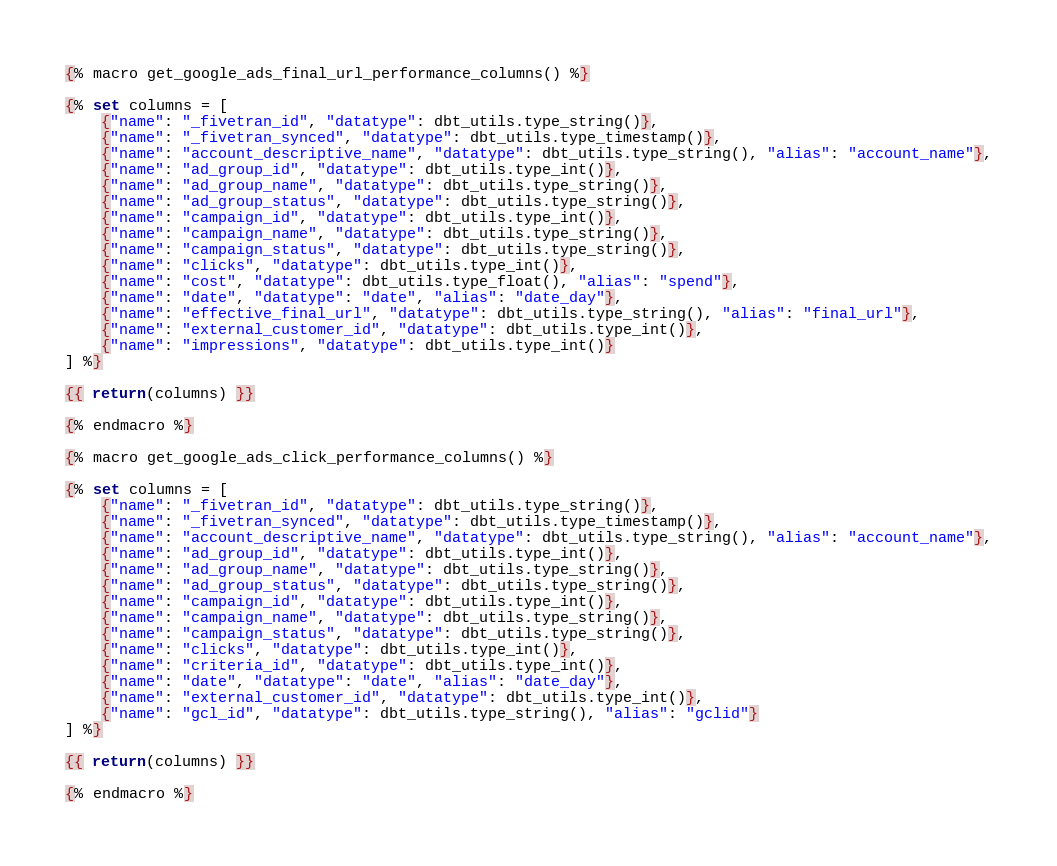<code> <loc_0><loc_0><loc_500><loc_500><_SQL_>{% macro get_google_ads_final_url_performance_columns() %}

{% set columns = [
    {"name": "_fivetran_id", "datatype": dbt_utils.type_string()},
    {"name": "_fivetran_synced", "datatype": dbt_utils.type_timestamp()},
    {"name": "account_descriptive_name", "datatype": dbt_utils.type_string(), "alias": "account_name"},
    {"name": "ad_group_id", "datatype": dbt_utils.type_int()},
    {"name": "ad_group_name", "datatype": dbt_utils.type_string()},
    {"name": "ad_group_status", "datatype": dbt_utils.type_string()},
    {"name": "campaign_id", "datatype": dbt_utils.type_int()},
    {"name": "campaign_name", "datatype": dbt_utils.type_string()},
    {"name": "campaign_status", "datatype": dbt_utils.type_string()},
    {"name": "clicks", "datatype": dbt_utils.type_int()},
    {"name": "cost", "datatype": dbt_utils.type_float(), "alias": "spend"},
    {"name": "date", "datatype": "date", "alias": "date_day"},
    {"name": "effective_final_url", "datatype": dbt_utils.type_string(), "alias": "final_url"},
    {"name": "external_customer_id", "datatype": dbt_utils.type_int()},
    {"name": "impressions", "datatype": dbt_utils.type_int()}
] %}

{{ return(columns) }}

{% endmacro %}

{% macro get_google_ads_click_performance_columns() %}

{% set columns = [
    {"name": "_fivetran_id", "datatype": dbt_utils.type_string()},
    {"name": "_fivetran_synced", "datatype": dbt_utils.type_timestamp()},
    {"name": "account_descriptive_name", "datatype": dbt_utils.type_string(), "alias": "account_name"},
    {"name": "ad_group_id", "datatype": dbt_utils.type_int()},
    {"name": "ad_group_name", "datatype": dbt_utils.type_string()},
    {"name": "ad_group_status", "datatype": dbt_utils.type_string()},
    {"name": "campaign_id", "datatype": dbt_utils.type_int()},
    {"name": "campaign_name", "datatype": dbt_utils.type_string()},
    {"name": "campaign_status", "datatype": dbt_utils.type_string()},
    {"name": "clicks", "datatype": dbt_utils.type_int()},
    {"name": "criteria_id", "datatype": dbt_utils.type_int()},
    {"name": "date", "datatype": "date", "alias": "date_day"},
    {"name": "external_customer_id", "datatype": dbt_utils.type_int()},
    {"name": "gcl_id", "datatype": dbt_utils.type_string(), "alias": "gclid"}
] %}

{{ return(columns) }}

{% endmacro %}
</code> 